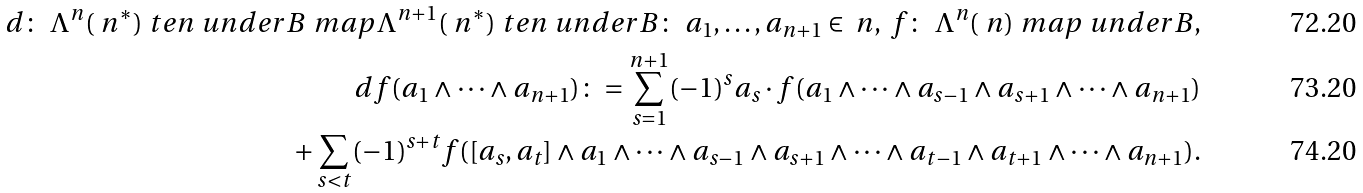<formula> <loc_0><loc_0><loc_500><loc_500>d \colon \ \Lambda ^ { n } ( \ n ^ { * } ) \ t e n \ u n d e r B \ m a p \Lambda ^ { n + 1 } ( \ n ^ { * } ) \ t e n \ u n d e r B \colon \ a _ { 1 } , \dots , a _ { n + 1 } \in \ n , \ f \colon \ \Lambda ^ { n } ( \ n ) \ m a p \ u n d e r B , \\ d f ( a _ { 1 } \wedge \dots \wedge a _ { n + 1 } ) \colon = \sum _ { s = 1 } ^ { n + 1 } ( - 1 ) ^ { s } a _ { s } \cdot f ( a _ { 1 } \wedge \dots \wedge a _ { s - 1 } \wedge a _ { s + 1 } \wedge \dots \wedge a _ { n + 1 } ) \\ + \sum _ { s < t } ( - 1 ) ^ { s + t } f ( [ a _ { s } , a _ { t } ] \wedge a _ { 1 } \wedge \dots \wedge a _ { s - 1 } \wedge a _ { s + 1 } \wedge \dots \wedge a _ { t - 1 } \wedge a _ { t + 1 } \wedge \dots \wedge a _ { n + 1 } ) .</formula> 